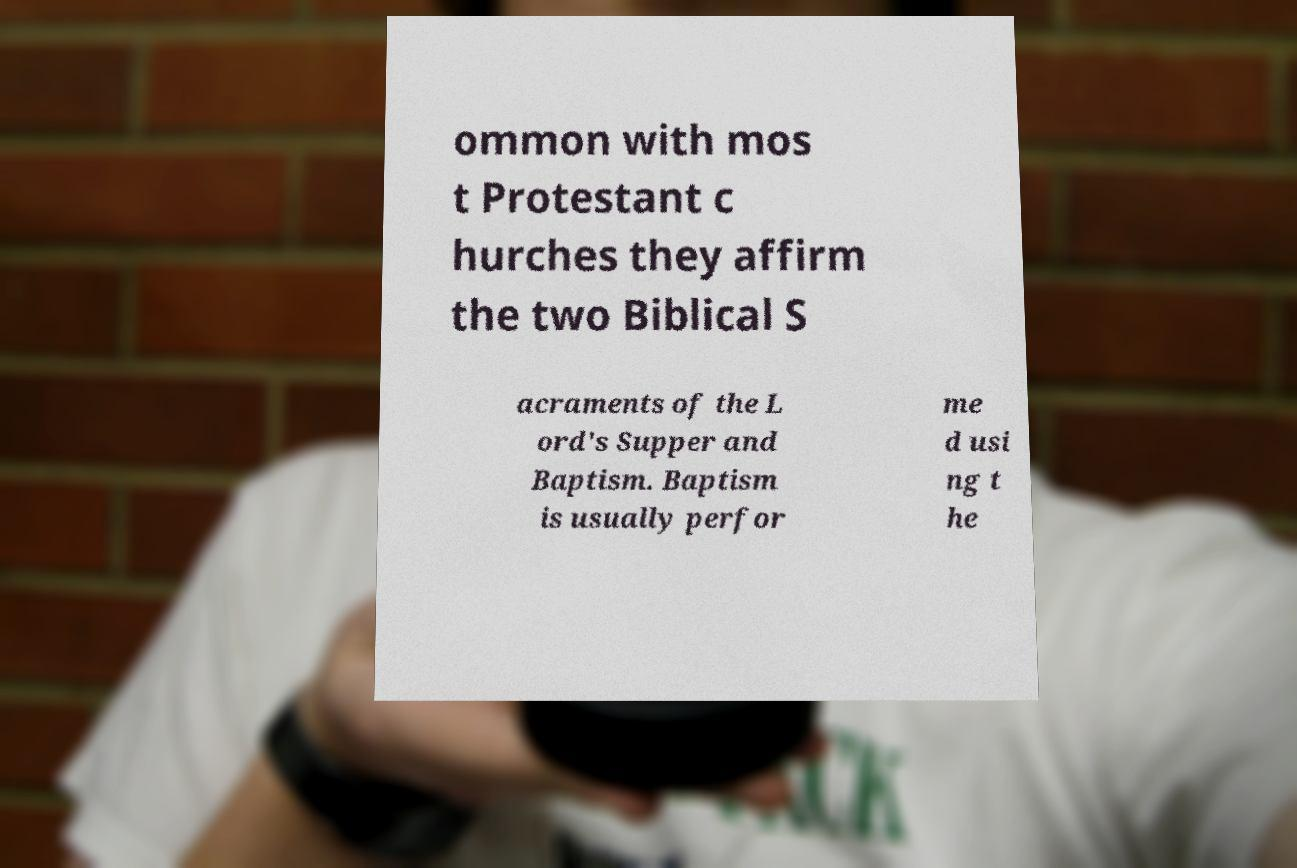Can you accurately transcribe the text from the provided image for me? ommon with mos t Protestant c hurches they affirm the two Biblical S acraments of the L ord's Supper and Baptism. Baptism is usually perfor me d usi ng t he 